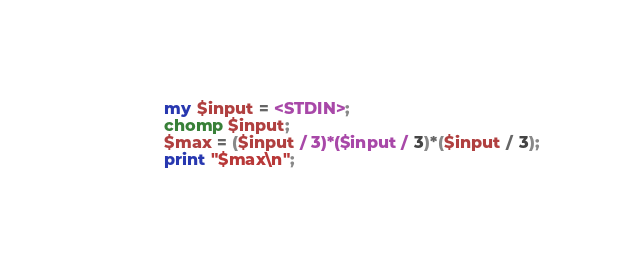Convert code to text. <code><loc_0><loc_0><loc_500><loc_500><_Perl_>	my $input = <STDIN>;
    chomp $input;
	$max = ($input / 3)*($input / 3)*($input / 3);
	print "$max\n";</code> 